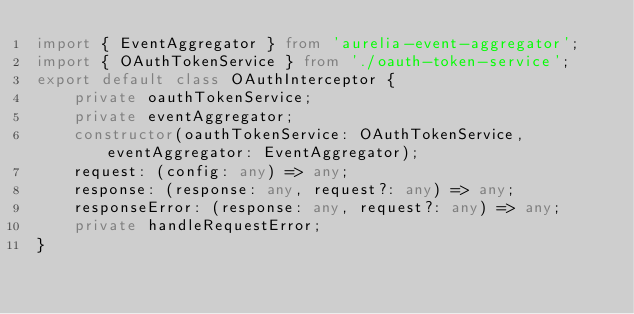Convert code to text. <code><loc_0><loc_0><loc_500><loc_500><_TypeScript_>import { EventAggregator } from 'aurelia-event-aggregator';
import { OAuthTokenService } from './oauth-token-service';
export default class OAuthInterceptor {
    private oauthTokenService;
    private eventAggregator;
    constructor(oauthTokenService: OAuthTokenService, eventAggregator: EventAggregator);
    request: (config: any) => any;
    response: (response: any, request?: any) => any;
    responseError: (response: any, request?: any) => any;
    private handleRequestError;
}
</code> 